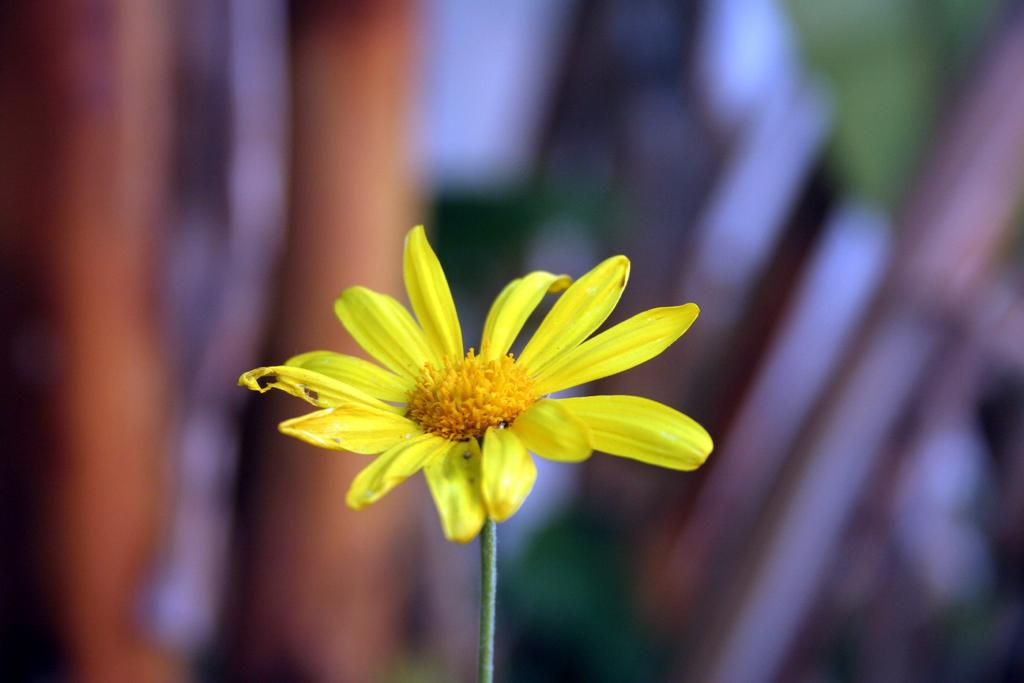What is the main subject of the image? There is a flower in the image. What color are the flower's petals? The flower's petals are yellow. What color is the flower's stem? The flower's stem is green. Can you describe the background of the image? The background of the image is blurred. What type of skin condition can be seen on the flower in the image? There is no skin condition present on the flower in the image, as flowers do not have skin. 